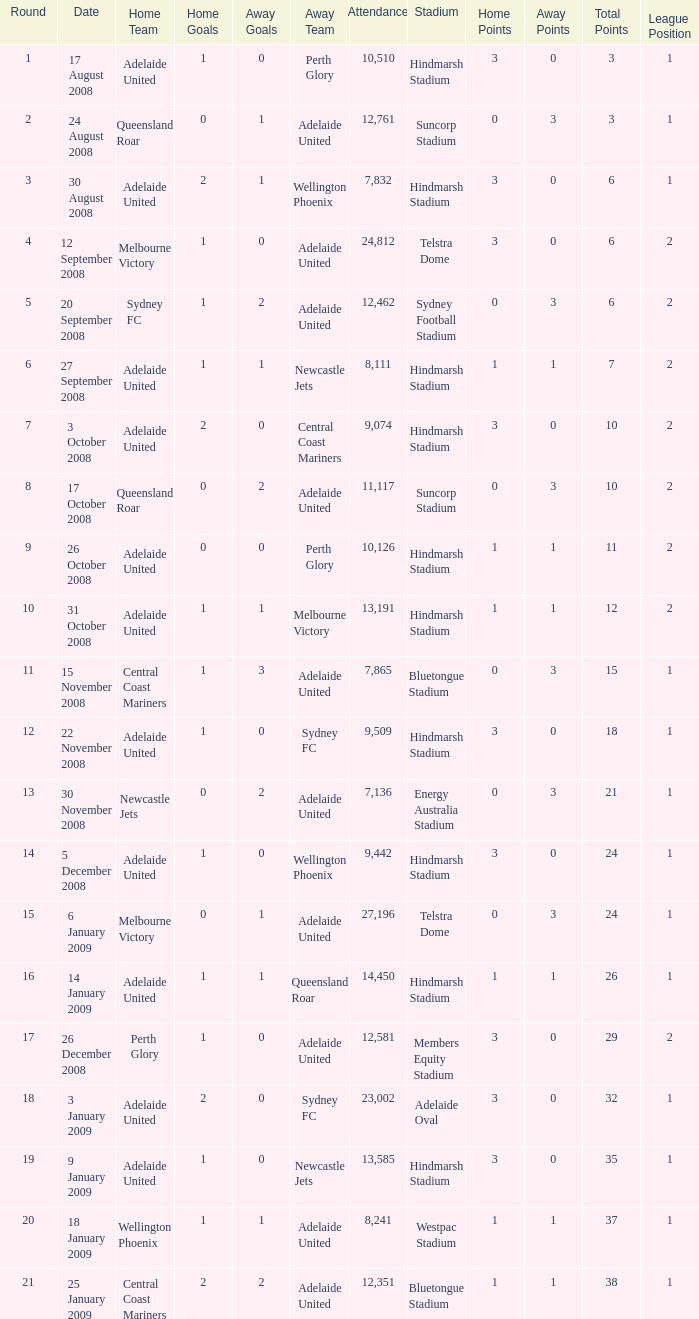What is the round when 11,117 people attended the game on 26 October 2008? 9.0. 